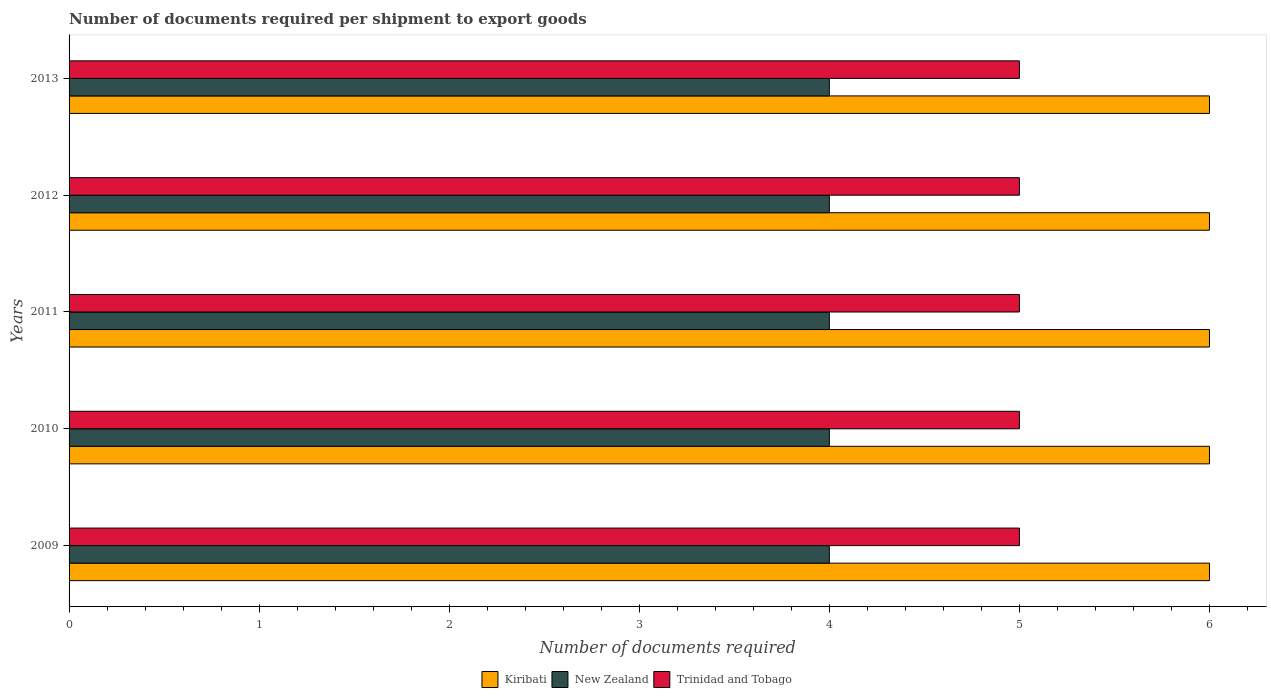How many different coloured bars are there?
Your answer should be compact. 3. How many bars are there on the 1st tick from the bottom?
Offer a very short reply. 3. What is the number of documents required per shipment to export goods in Kiribati in 2010?
Keep it short and to the point. 6. Across all years, what is the minimum number of documents required per shipment to export goods in New Zealand?
Offer a terse response. 4. In which year was the number of documents required per shipment to export goods in Kiribati maximum?
Offer a very short reply. 2009. In which year was the number of documents required per shipment to export goods in New Zealand minimum?
Ensure brevity in your answer.  2009. What is the total number of documents required per shipment to export goods in Kiribati in the graph?
Make the answer very short. 30. What is the difference between the number of documents required per shipment to export goods in Kiribati in 2012 and that in 2013?
Keep it short and to the point. 0. What is the difference between the number of documents required per shipment to export goods in Kiribati in 2009 and the number of documents required per shipment to export goods in Trinidad and Tobago in 2011?
Keep it short and to the point. 1. In the year 2010, what is the difference between the number of documents required per shipment to export goods in Trinidad and Tobago and number of documents required per shipment to export goods in New Zealand?
Offer a very short reply. 1. What is the ratio of the number of documents required per shipment to export goods in Trinidad and Tobago in 2010 to that in 2013?
Keep it short and to the point. 1. Is the difference between the number of documents required per shipment to export goods in Trinidad and Tobago in 2010 and 2012 greater than the difference between the number of documents required per shipment to export goods in New Zealand in 2010 and 2012?
Your answer should be compact. No. What is the difference between the highest and the lowest number of documents required per shipment to export goods in Kiribati?
Offer a very short reply. 0. In how many years, is the number of documents required per shipment to export goods in New Zealand greater than the average number of documents required per shipment to export goods in New Zealand taken over all years?
Provide a succinct answer. 0. What does the 2nd bar from the top in 2012 represents?
Your response must be concise. New Zealand. What does the 3rd bar from the bottom in 2012 represents?
Make the answer very short. Trinidad and Tobago. Are all the bars in the graph horizontal?
Make the answer very short. Yes. Are the values on the major ticks of X-axis written in scientific E-notation?
Your answer should be very brief. No. Where does the legend appear in the graph?
Offer a very short reply. Bottom center. How many legend labels are there?
Ensure brevity in your answer.  3. How are the legend labels stacked?
Your answer should be very brief. Horizontal. What is the title of the graph?
Provide a short and direct response. Number of documents required per shipment to export goods. What is the label or title of the X-axis?
Provide a succinct answer. Number of documents required. What is the label or title of the Y-axis?
Your response must be concise. Years. What is the Number of documents required in Trinidad and Tobago in 2009?
Provide a short and direct response. 5. What is the Number of documents required in Kiribati in 2010?
Give a very brief answer. 6. What is the Number of documents required in New Zealand in 2010?
Keep it short and to the point. 4. What is the Number of documents required of Kiribati in 2011?
Give a very brief answer. 6. What is the Number of documents required of Trinidad and Tobago in 2012?
Your response must be concise. 5. What is the Number of documents required in Kiribati in 2013?
Make the answer very short. 6. What is the Number of documents required of New Zealand in 2013?
Provide a short and direct response. 4. What is the Number of documents required in Trinidad and Tobago in 2013?
Offer a very short reply. 5. Across all years, what is the maximum Number of documents required in Kiribati?
Provide a short and direct response. 6. Across all years, what is the maximum Number of documents required of New Zealand?
Provide a succinct answer. 4. Across all years, what is the minimum Number of documents required of Kiribati?
Offer a terse response. 6. What is the difference between the Number of documents required of New Zealand in 2009 and that in 2010?
Ensure brevity in your answer.  0. What is the difference between the Number of documents required of New Zealand in 2009 and that in 2011?
Offer a terse response. 0. What is the difference between the Number of documents required in Trinidad and Tobago in 2009 and that in 2011?
Your answer should be very brief. 0. What is the difference between the Number of documents required in Kiribati in 2009 and that in 2012?
Offer a very short reply. 0. What is the difference between the Number of documents required in New Zealand in 2009 and that in 2013?
Your response must be concise. 0. What is the difference between the Number of documents required in Trinidad and Tobago in 2010 and that in 2011?
Provide a short and direct response. 0. What is the difference between the Number of documents required in New Zealand in 2010 and that in 2012?
Provide a succinct answer. 0. What is the difference between the Number of documents required of Trinidad and Tobago in 2010 and that in 2012?
Offer a terse response. 0. What is the difference between the Number of documents required in New Zealand in 2010 and that in 2013?
Keep it short and to the point. 0. What is the difference between the Number of documents required in Kiribati in 2011 and that in 2012?
Make the answer very short. 0. What is the difference between the Number of documents required in Trinidad and Tobago in 2011 and that in 2013?
Make the answer very short. 0. What is the difference between the Number of documents required in Kiribati in 2012 and that in 2013?
Give a very brief answer. 0. What is the difference between the Number of documents required of New Zealand in 2009 and the Number of documents required of Trinidad and Tobago in 2010?
Provide a succinct answer. -1. What is the difference between the Number of documents required of Kiribati in 2009 and the Number of documents required of New Zealand in 2011?
Offer a terse response. 2. What is the difference between the Number of documents required in Kiribati in 2009 and the Number of documents required in Trinidad and Tobago in 2011?
Provide a succinct answer. 1. What is the difference between the Number of documents required in New Zealand in 2009 and the Number of documents required in Trinidad and Tobago in 2011?
Offer a very short reply. -1. What is the difference between the Number of documents required of Kiribati in 2009 and the Number of documents required of New Zealand in 2012?
Provide a short and direct response. 2. What is the difference between the Number of documents required of Kiribati in 2009 and the Number of documents required of Trinidad and Tobago in 2012?
Make the answer very short. 1. What is the difference between the Number of documents required of New Zealand in 2009 and the Number of documents required of Trinidad and Tobago in 2012?
Make the answer very short. -1. What is the difference between the Number of documents required of New Zealand in 2009 and the Number of documents required of Trinidad and Tobago in 2013?
Offer a very short reply. -1. What is the difference between the Number of documents required of Kiribati in 2010 and the Number of documents required of New Zealand in 2012?
Make the answer very short. 2. What is the difference between the Number of documents required of Kiribati in 2010 and the Number of documents required of Trinidad and Tobago in 2012?
Your answer should be very brief. 1. What is the difference between the Number of documents required of New Zealand in 2010 and the Number of documents required of Trinidad and Tobago in 2012?
Offer a terse response. -1. What is the difference between the Number of documents required of Kiribati in 2010 and the Number of documents required of Trinidad and Tobago in 2013?
Offer a very short reply. 1. What is the difference between the Number of documents required of Kiribati in 2011 and the Number of documents required of Trinidad and Tobago in 2012?
Ensure brevity in your answer.  1. What is the average Number of documents required in Kiribati per year?
Ensure brevity in your answer.  6. What is the average Number of documents required in New Zealand per year?
Give a very brief answer. 4. What is the average Number of documents required in Trinidad and Tobago per year?
Provide a short and direct response. 5. In the year 2009, what is the difference between the Number of documents required in Kiribati and Number of documents required in New Zealand?
Your response must be concise. 2. In the year 2009, what is the difference between the Number of documents required in Kiribati and Number of documents required in Trinidad and Tobago?
Provide a short and direct response. 1. In the year 2010, what is the difference between the Number of documents required of Kiribati and Number of documents required of Trinidad and Tobago?
Ensure brevity in your answer.  1. In the year 2011, what is the difference between the Number of documents required of Kiribati and Number of documents required of New Zealand?
Provide a succinct answer. 2. In the year 2012, what is the difference between the Number of documents required of Kiribati and Number of documents required of New Zealand?
Provide a short and direct response. 2. In the year 2012, what is the difference between the Number of documents required in Kiribati and Number of documents required in Trinidad and Tobago?
Provide a short and direct response. 1. In the year 2012, what is the difference between the Number of documents required of New Zealand and Number of documents required of Trinidad and Tobago?
Your response must be concise. -1. In the year 2013, what is the difference between the Number of documents required of Kiribati and Number of documents required of Trinidad and Tobago?
Your answer should be very brief. 1. What is the ratio of the Number of documents required of Kiribati in 2009 to that in 2011?
Provide a short and direct response. 1. What is the ratio of the Number of documents required of New Zealand in 2009 to that in 2011?
Keep it short and to the point. 1. What is the ratio of the Number of documents required in Trinidad and Tobago in 2009 to that in 2011?
Your answer should be compact. 1. What is the ratio of the Number of documents required of Kiribati in 2009 to that in 2012?
Keep it short and to the point. 1. What is the ratio of the Number of documents required in New Zealand in 2009 to that in 2012?
Ensure brevity in your answer.  1. What is the ratio of the Number of documents required in Trinidad and Tobago in 2009 to that in 2013?
Offer a very short reply. 1. What is the ratio of the Number of documents required of Kiribati in 2010 to that in 2011?
Make the answer very short. 1. What is the ratio of the Number of documents required of Kiribati in 2010 to that in 2012?
Your answer should be compact. 1. What is the ratio of the Number of documents required in New Zealand in 2010 to that in 2013?
Make the answer very short. 1. What is the ratio of the Number of documents required in New Zealand in 2011 to that in 2012?
Your response must be concise. 1. What is the ratio of the Number of documents required in Trinidad and Tobago in 2011 to that in 2012?
Ensure brevity in your answer.  1. What is the ratio of the Number of documents required in Trinidad and Tobago in 2011 to that in 2013?
Ensure brevity in your answer.  1. What is the ratio of the Number of documents required of New Zealand in 2012 to that in 2013?
Provide a succinct answer. 1. What is the difference between the highest and the second highest Number of documents required in Kiribati?
Offer a very short reply. 0. What is the difference between the highest and the second highest Number of documents required of New Zealand?
Keep it short and to the point. 0. What is the difference between the highest and the second highest Number of documents required in Trinidad and Tobago?
Offer a very short reply. 0. What is the difference between the highest and the lowest Number of documents required of New Zealand?
Your response must be concise. 0. 